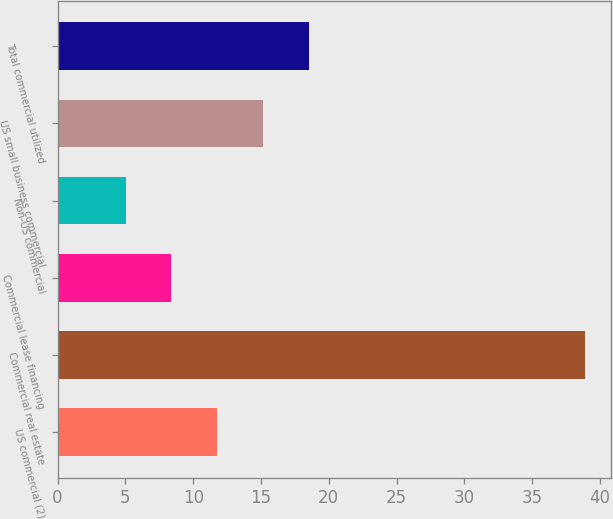Convert chart. <chart><loc_0><loc_0><loc_500><loc_500><bar_chart><fcel>US commercial (2)<fcel>Commercial real estate<fcel>Commercial lease financing<fcel>Non-US commercial<fcel>US small business commercial<fcel>Total commercial utilized<nl><fcel>11.79<fcel>38.88<fcel>8.4<fcel>5.01<fcel>15.18<fcel>18.57<nl></chart> 